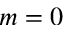<formula> <loc_0><loc_0><loc_500><loc_500>m = 0</formula> 